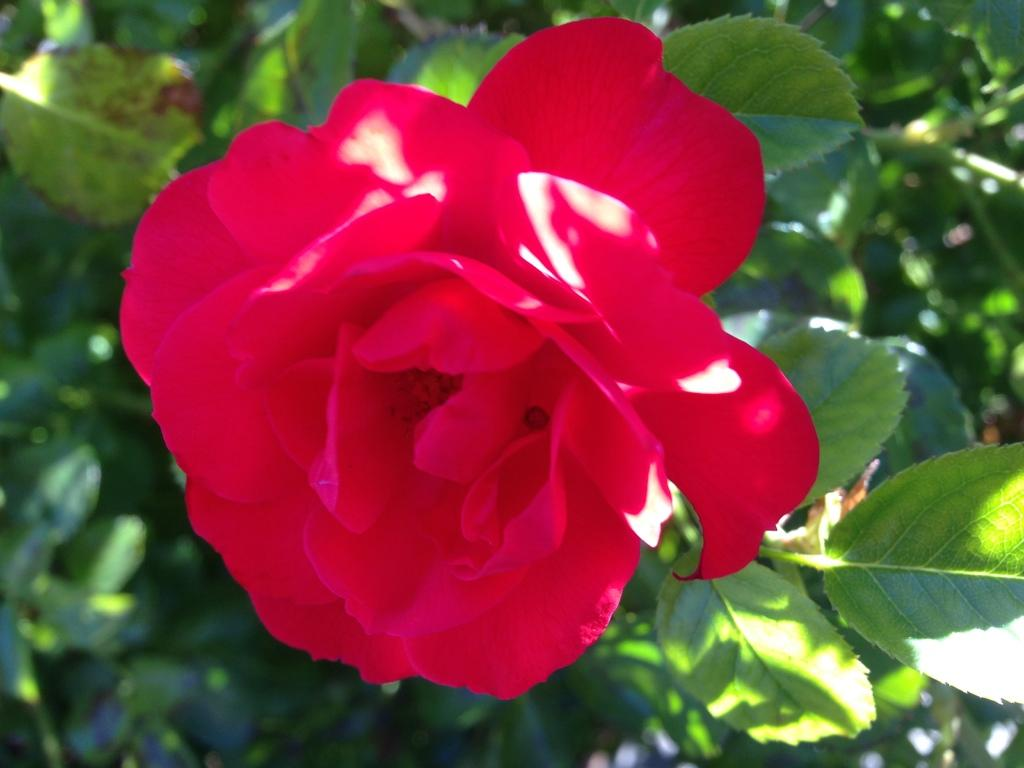What type of flower is in the image? There is a rose flower on a stem in the image. Can you describe the background of the image? The background is green and blurred. What type of fruit is hanging from the rose flower in the image? There is no fruit present in the image; it features a rose flower on a stem. How many visitors can be seen interacting with the rose flower in the image? There are no visitors present in the image; it only shows a rose flower on a stem with a green and blurred background. 